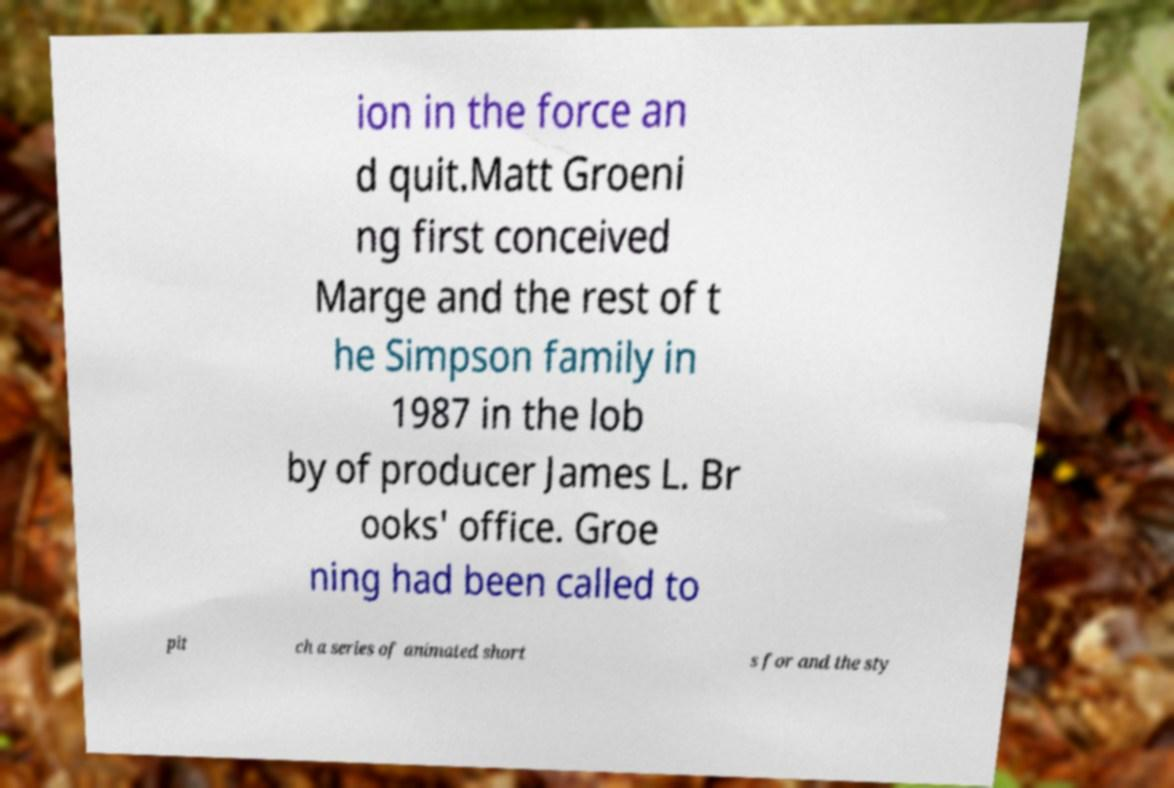There's text embedded in this image that I need extracted. Can you transcribe it verbatim? ion in the force an d quit.Matt Groeni ng first conceived Marge and the rest of t he Simpson family in 1987 in the lob by of producer James L. Br ooks' office. Groe ning had been called to pit ch a series of animated short s for and the sty 